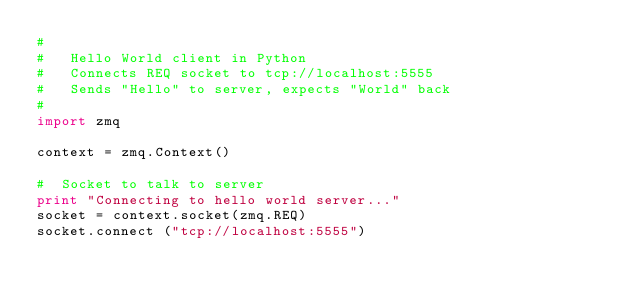Convert code to text. <code><loc_0><loc_0><loc_500><loc_500><_Python_>#
#   Hello World client in Python
#   Connects REQ socket to tcp://localhost:5555
#   Sends "Hello" to server, expects "World" back
#
import zmq

context = zmq.Context()

#  Socket to talk to server
print "Connecting to hello world server..."
socket = context.socket(zmq.REQ)
socket.connect ("tcp://localhost:5555")
</code> 